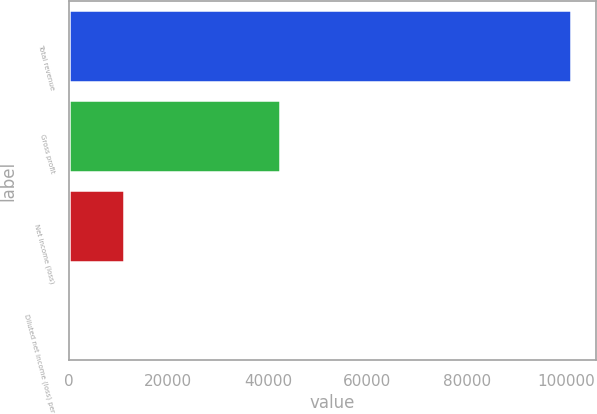Convert chart. <chart><loc_0><loc_0><loc_500><loc_500><bar_chart><fcel>Total revenue<fcel>Gross profit<fcel>Net income (loss)<fcel>Diluted net income (loss) per<nl><fcel>100985<fcel>42429<fcel>11164<fcel>0.24<nl></chart> 